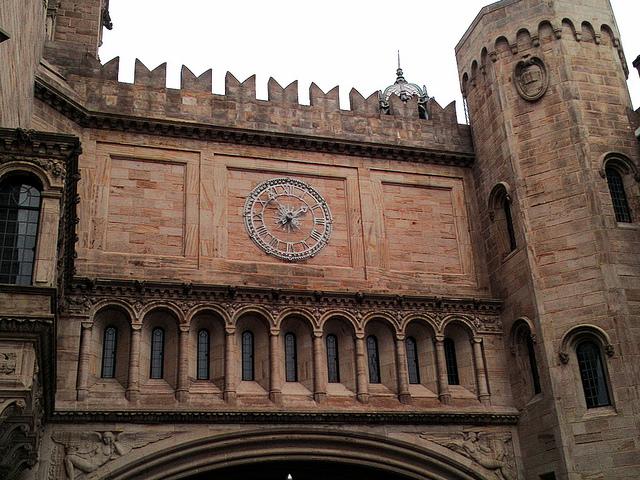How many panels on either side of the clock?
Write a very short answer. 2. Is this art deco?
Give a very brief answer. No. Where is the clock?
Short answer required. On building. What time is it?
Be succinct. I can't tell. How many archways are visible?
Concise answer only. 1. What time is the clock displaying?
Quick response, please. 1:55. What time does the clock show?
Give a very brief answer. 1:55. Are the clocks trimmed in gold?
Write a very short answer. No. Is the building old?
Answer briefly. Yes. 